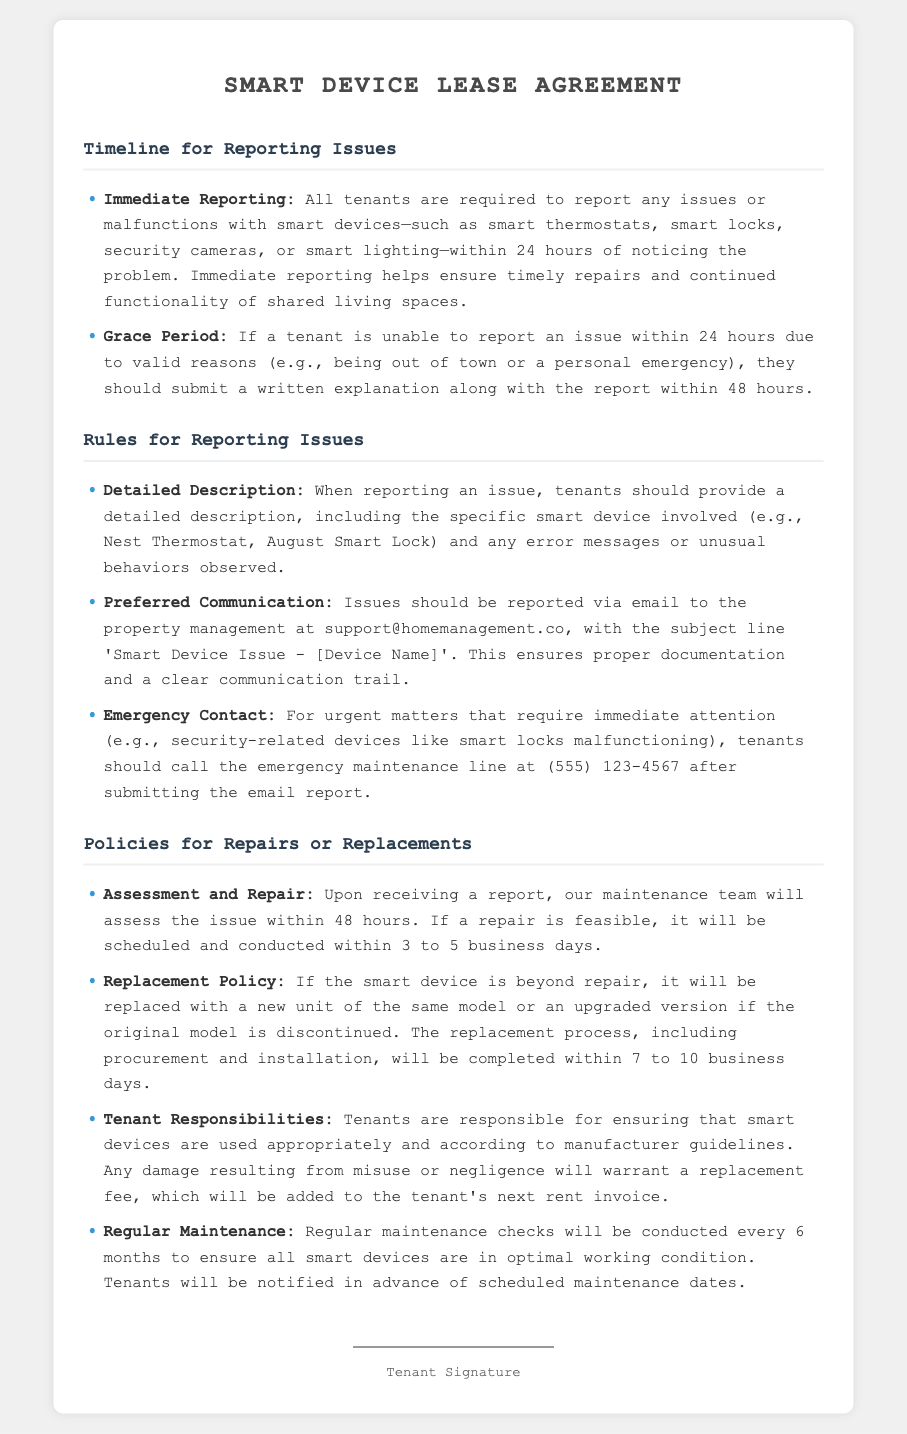what is the required time frame for reporting smart device issues? Tenants must report any issues within 24 hours of noticing the problem.
Answer: 24 hours what should tenants include in their issue report? A detailed description is required, including the specific smart device and any observed error messages or unusual behaviors.
Answer: Detailed description how long does the maintenance team have to assess an issue after it's reported? The maintenance team must assess the issue within 48 hours of receiving the report.
Answer: 48 hours what is the possible time frame for a repair to be conducted after assessment? Repairs will be scheduled and conducted within 3 to 5 business days after assessment.
Answer: 3 to 5 business days what happens if a smart device cannot be repaired? If the device is beyond repair, it will be replaced with a new unit of the same model or an upgraded version.
Answer: Replacement what should tenants do in case of an urgent issue with a smart lock? Tenants should call the emergency maintenance line after submitting the email report.
Answer: Call emergency maintenance line how often will regular maintenance checks occur for smart devices? Regular maintenance checks will occur every 6 months.
Answer: Every 6 months if a tenant causes damage to a smart device, what will happen? Damage resulting from misuse or negligence will warrant a replacement fee added to the next rent invoice.
Answer: Replacement fee what email should tenants use to report a smart device issue? Issues should be reported via email to support@homemanagement.co.
Answer: support@homemanagement.co 